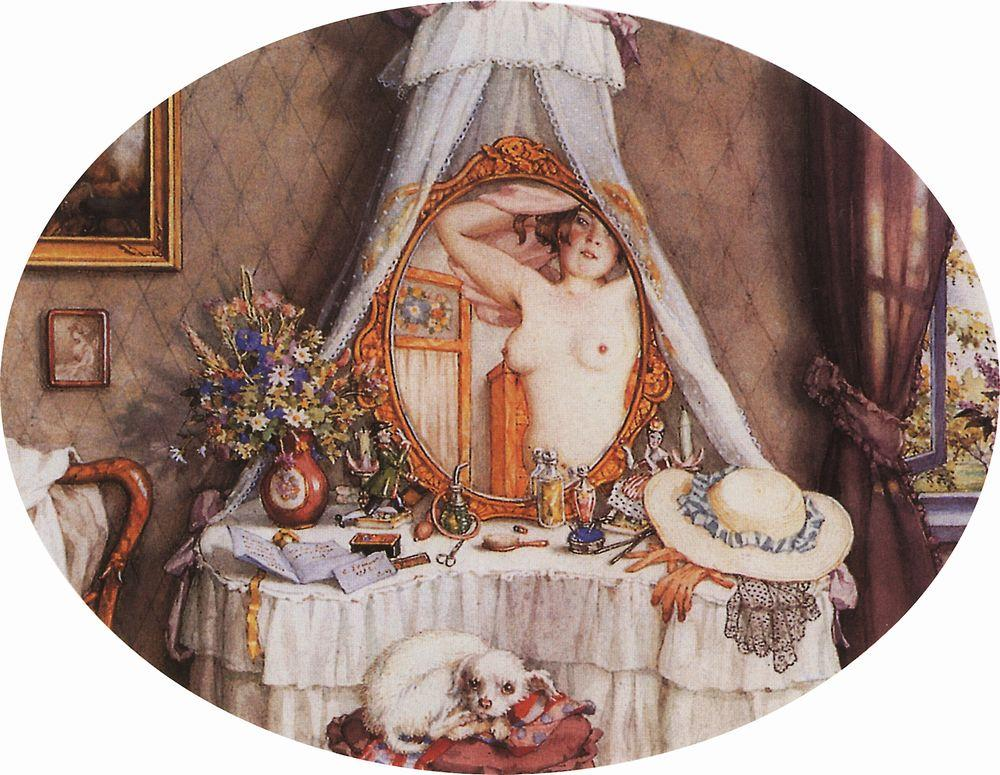Can you describe the mood conveyed by this image? The mood of this image is one of serene intimacy and quiet contemplation. The warm, soft colors and gentle lighting create a comforting ambiance. The woman’s relaxed posture and the small, resting dog contribute to a sense of calm and tranquility. The assortment of personal items on the vanity, such as the hat, flowers, and various trinkets, add a nostalgic and personal touch, evoking a feeling of cherished private moments. 